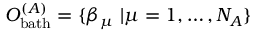Convert formula to latex. <formula><loc_0><loc_0><loc_500><loc_500>O _ { b a t h } ^ { ( A ) } = \{ \beta _ { \mu } \ | \mu = 1 , \dots , N _ { A } \}</formula> 